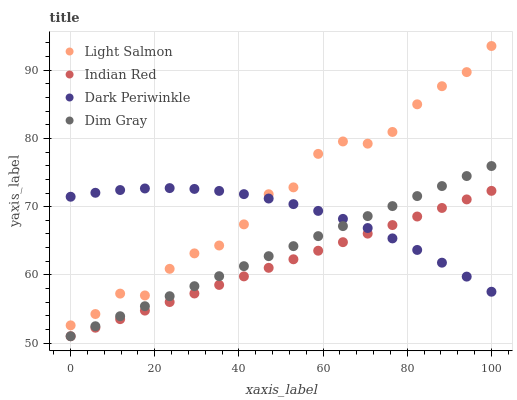Does Indian Red have the minimum area under the curve?
Answer yes or no. Yes. Does Light Salmon have the maximum area under the curve?
Answer yes or no. Yes. Does Dim Gray have the minimum area under the curve?
Answer yes or no. No. Does Dim Gray have the maximum area under the curve?
Answer yes or no. No. Is Dim Gray the smoothest?
Answer yes or no. Yes. Is Light Salmon the roughest?
Answer yes or no. Yes. Is Dark Periwinkle the smoothest?
Answer yes or no. No. Is Dark Periwinkle the roughest?
Answer yes or no. No. Does Dim Gray have the lowest value?
Answer yes or no. Yes. Does Dark Periwinkle have the lowest value?
Answer yes or no. No. Does Light Salmon have the highest value?
Answer yes or no. Yes. Does Dim Gray have the highest value?
Answer yes or no. No. Is Indian Red less than Light Salmon?
Answer yes or no. Yes. Is Light Salmon greater than Indian Red?
Answer yes or no. Yes. Does Indian Red intersect Dark Periwinkle?
Answer yes or no. Yes. Is Indian Red less than Dark Periwinkle?
Answer yes or no. No. Is Indian Red greater than Dark Periwinkle?
Answer yes or no. No. Does Indian Red intersect Light Salmon?
Answer yes or no. No. 